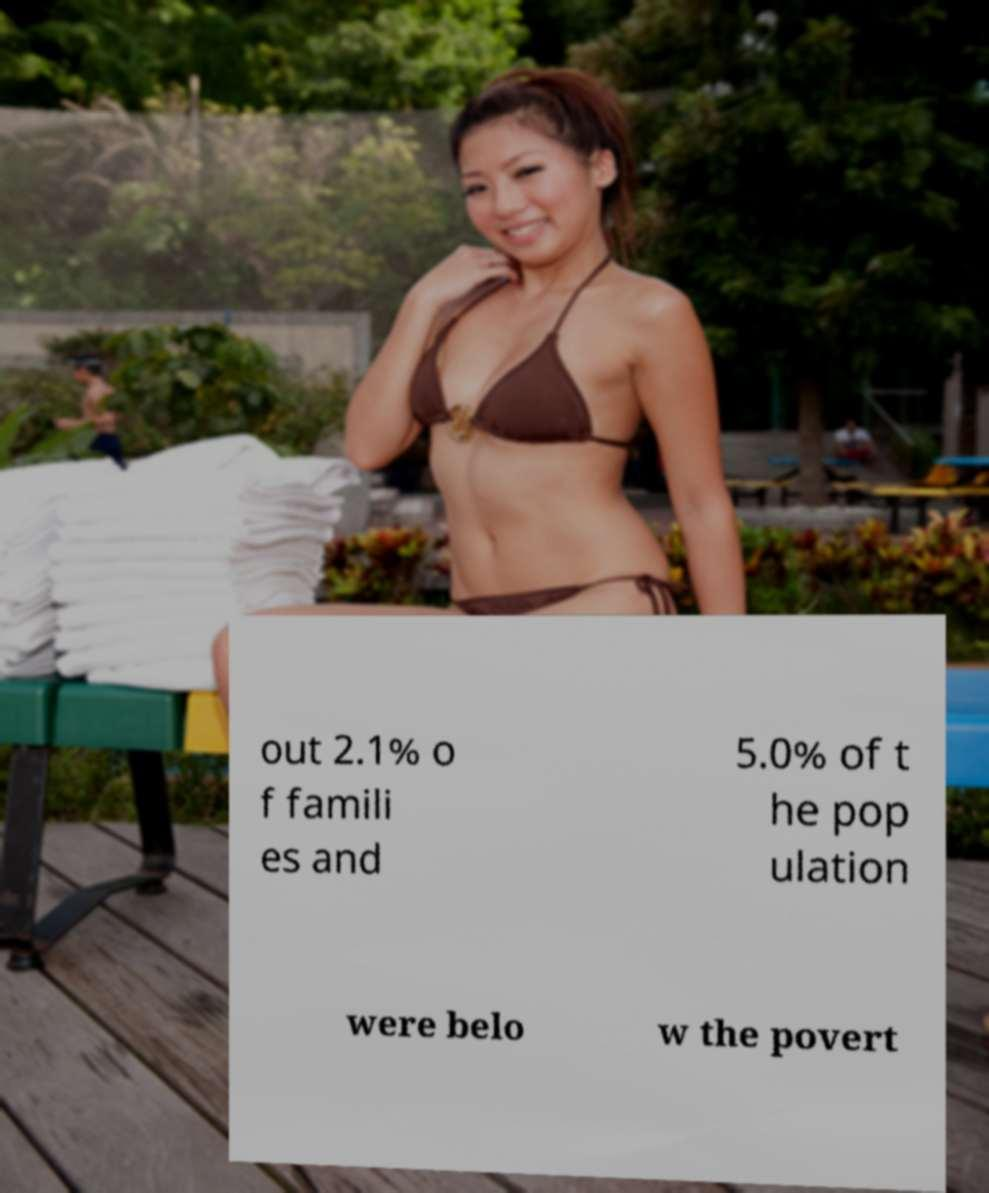For documentation purposes, I need the text within this image transcribed. Could you provide that? out 2.1% o f famili es and 5.0% of t he pop ulation were belo w the povert 